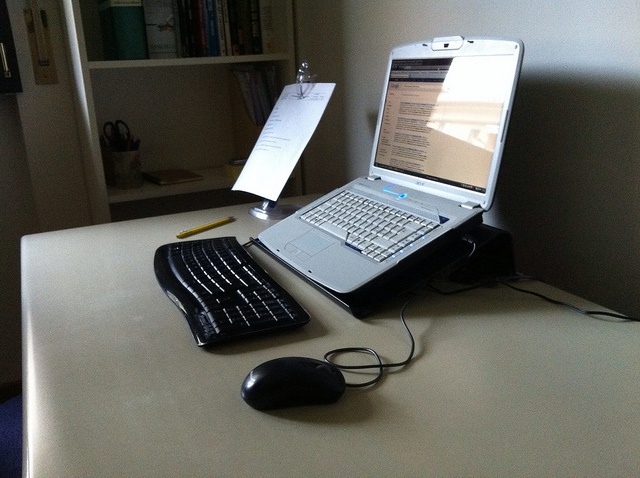Describe the objects in this image and their specific colors. I can see laptop in black, white, darkgray, and gray tones, keyboard in black, gray, and darkgray tones, mouse in black, gray, white, and darkgray tones, keyboard in black, darkgray, and lightgray tones, and book in black tones in this image. 